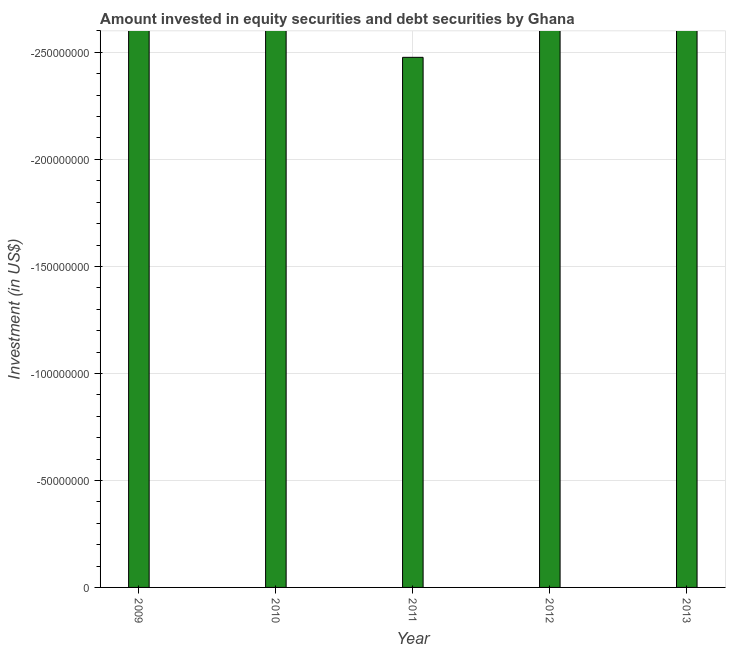What is the title of the graph?
Provide a short and direct response. Amount invested in equity securities and debt securities by Ghana. What is the label or title of the X-axis?
Offer a very short reply. Year. What is the label or title of the Y-axis?
Offer a very short reply. Investment (in US$). What is the sum of the portfolio investment?
Make the answer very short. 0. In how many years, is the portfolio investment greater than the average portfolio investment taken over all years?
Keep it short and to the point. 0. Are all the bars in the graph horizontal?
Provide a succinct answer. No. How many years are there in the graph?
Your answer should be very brief. 5. What is the difference between two consecutive major ticks on the Y-axis?
Provide a succinct answer. 5.00e+07. What is the Investment (in US$) in 2011?
Provide a short and direct response. 0. What is the Investment (in US$) of 2012?
Provide a short and direct response. 0. What is the Investment (in US$) of 2013?
Provide a short and direct response. 0. 